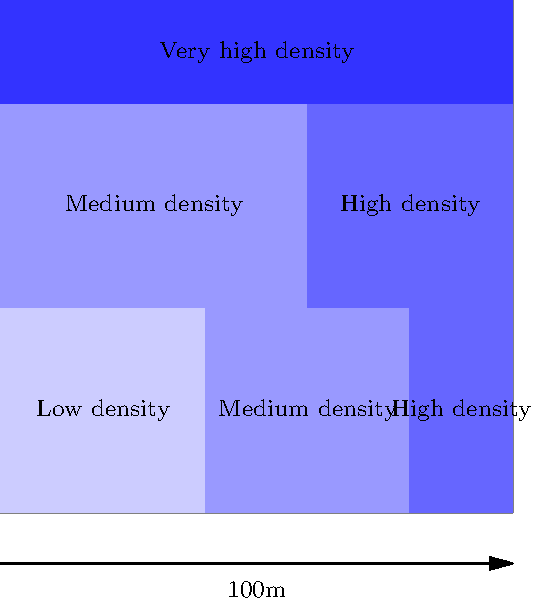Based on the aerial view image of a previous parade, estimate the total number of attendees. Each grid square represents a 10m x 10m area. Assume the following crowd densities:
- Low density: 2 people per square meter
- Medium density: 4 people per square meter
- High density: 6 people per square meter
- Very high density: 8 people per square meter To estimate the total number of attendees, we need to calculate the area and number of people for each density level, then sum them up:

1. Low density area:
   - 4 grid squares = 4 * (10m * 10m) = 400 m²
   - People: 400 m² * 2 people/m² = 800 people

2. Medium density area:
   - 6 grid squares = 6 * (10m * 10m) = 600 m²
   - People: 600 m² * 4 people/m² = 2,400 people

3. High density area:
   - 6 grid squares = 6 * (10m * 10m) = 600 m²
   - People: 600 m² * 6 people/m² = 3,600 people

4. Very high density area:
   - 4 grid squares = 4 * (10m * 10m) = 400 m²
   - People: 400 m² * 8 people/m² = 3,200 people

Total number of attendees:
$800 + 2,400 + 3,600 + 3,200 = 10,000$ people
Answer: 10,000 people 